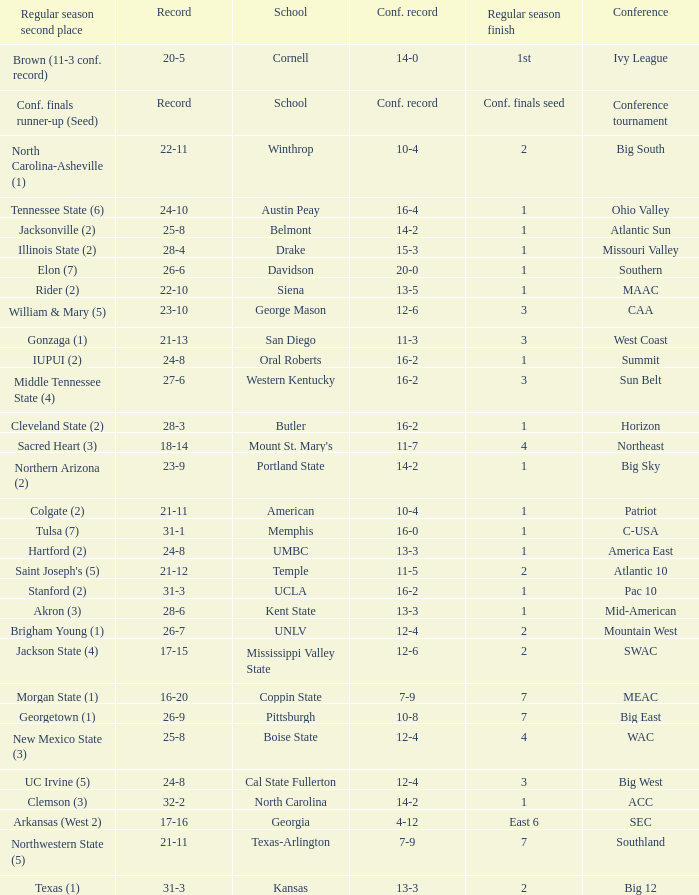For teams in the Sun Belt conference, what is the conference record? 16-2. 